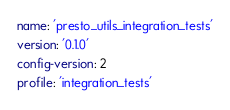<code> <loc_0><loc_0><loc_500><loc_500><_YAML_>name: 'presto_utils_integration_tests'
version: '0.1.0'
config-version: 2
profile: 'integration_tests'

</code> 